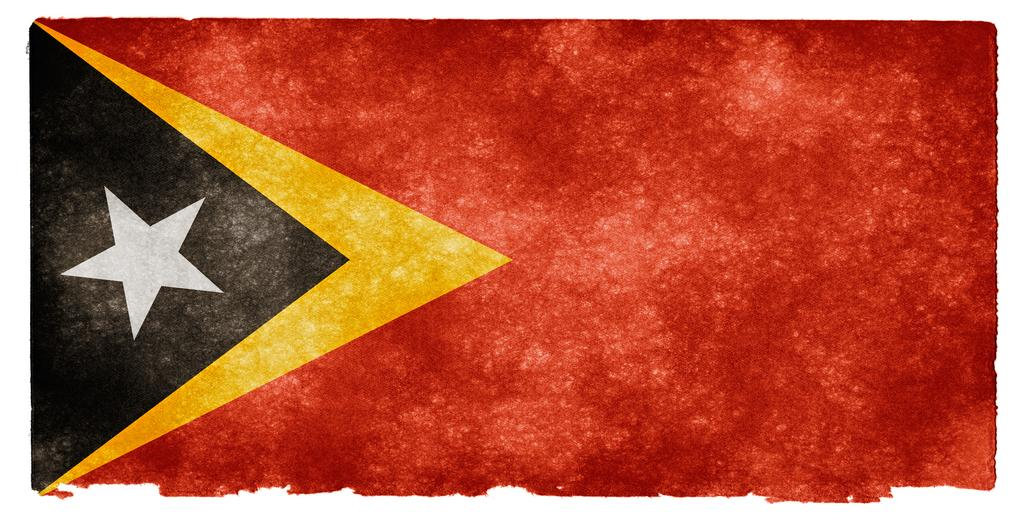What is depicted in the image? There is a picture of a flag in the image. Can you describe the colors used in the flag? The flag involves red, yellow, black, and white colors. What type of cabbage is being served to the governor on the route in the image? There is no cabbage, governor, or route present in the image; it only features a picture of a flag. 